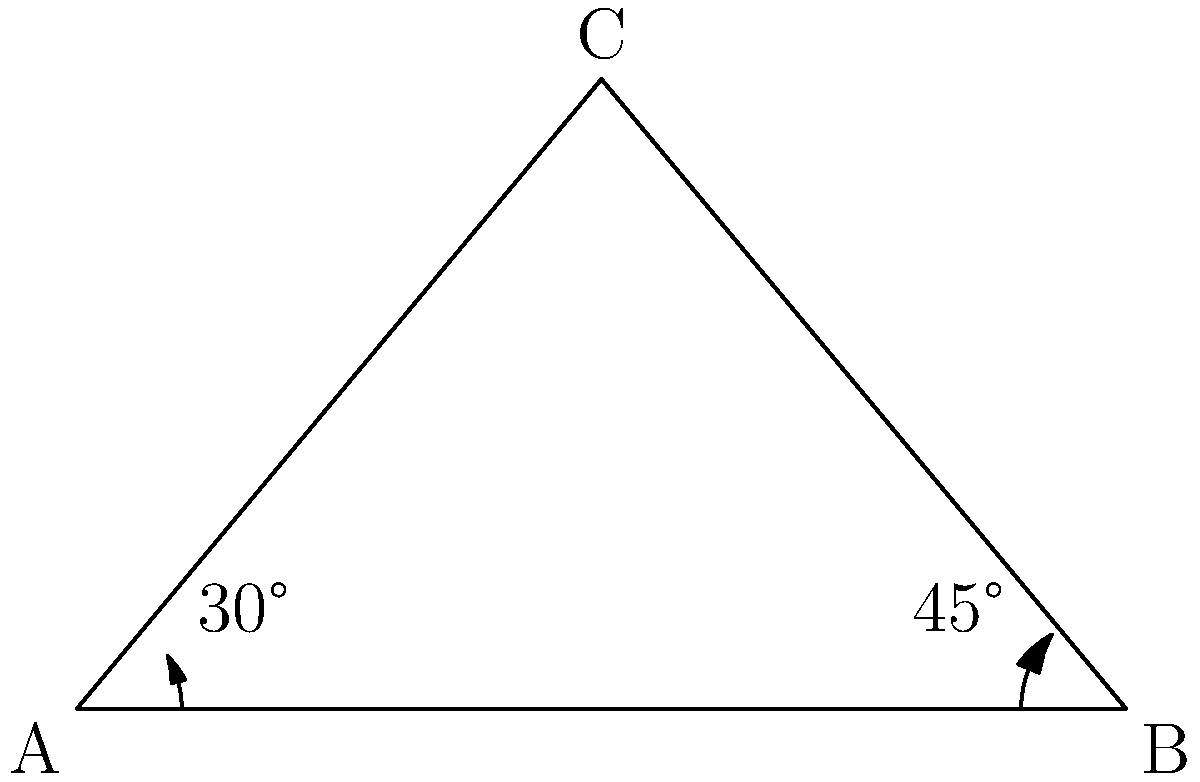In a manufacturing facility, two conveyor belts meet at point C, forming a triangle with the floor. The angle between the floor and the first conveyor belt is 30°, while the angle between the floor and the second conveyor belt is 45°. What is the angle between the two conveyor belts? Let's approach this step-by-step:

1) In the triangle ABC, we know two angles:
   - Angle BAC = 30°
   - Angle ABC = 45°

2) In any triangle, the sum of all angles is always 180°. We can use this to find the third angle (ACB):

   $$180° = 30° + 45° + ACB$$

3) Solving for ACB:

   $$ACB = 180° - 30° - 45° = 105°$$

4) The angle we're looking for is the angle between the two conveyor belts, which is the supplement of angle ACB (the angle that, when added to ACB, makes 180°).

5) To find this, we subtract ACB from 180°:

   $$180° - 105° = 75°$$

Therefore, the angle between the two conveyor belts is 75°.
Answer: 75° 